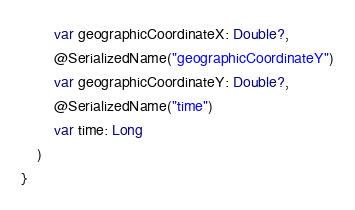Convert code to text. <code><loc_0><loc_0><loc_500><loc_500><_Kotlin_>        var geographicCoordinateX: Double?,
        @SerializedName("geographicCoordinateY")
        var geographicCoordinateY: Double?,
        @SerializedName("time")
        var time: Long
    )
}</code> 